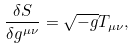<formula> <loc_0><loc_0><loc_500><loc_500>\frac { \delta S } { \delta g ^ { \mu \nu } } = \sqrt { - g } T _ { \mu \nu } ,</formula> 